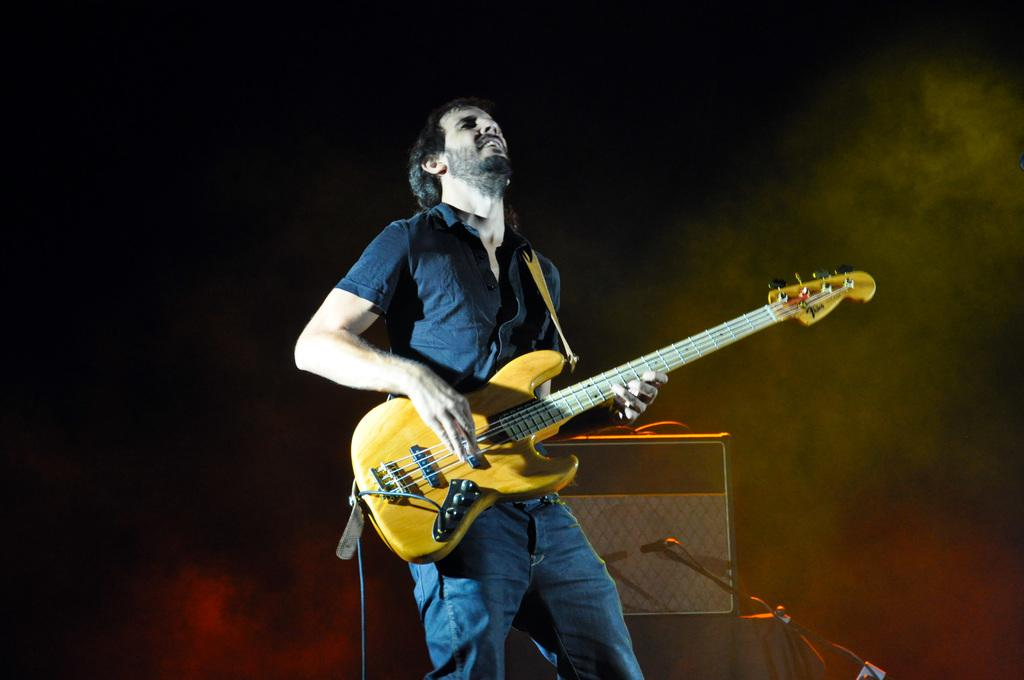What is the main subject of the image? There is a man standing in the center of the image. What is the man holding in his hand? The man is holding a guitar in his hand. What else can be seen in the middle of the image? There is a musical instrument and a mic stand present in the middle of the image. What type of railway is visible in the background of the image? There is no railway visible in the background of the image. What color is the man's underwear in the image? The man's underwear is not visible in the image, so we cannot determine its color. 